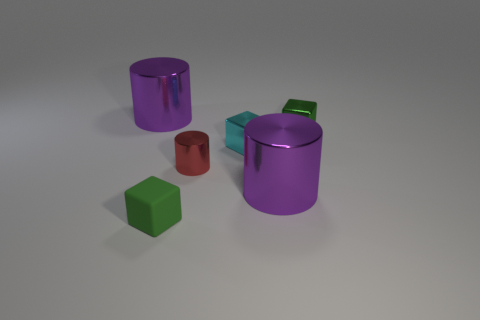Add 2 red shiny objects. How many objects exist? 8 Subtract all purple metallic things. Subtract all tiny metal objects. How many objects are left? 1 Add 1 tiny metallic cylinders. How many tiny metallic cylinders are left? 2 Add 4 purple metallic cylinders. How many purple metallic cylinders exist? 6 Subtract 2 purple cylinders. How many objects are left? 4 